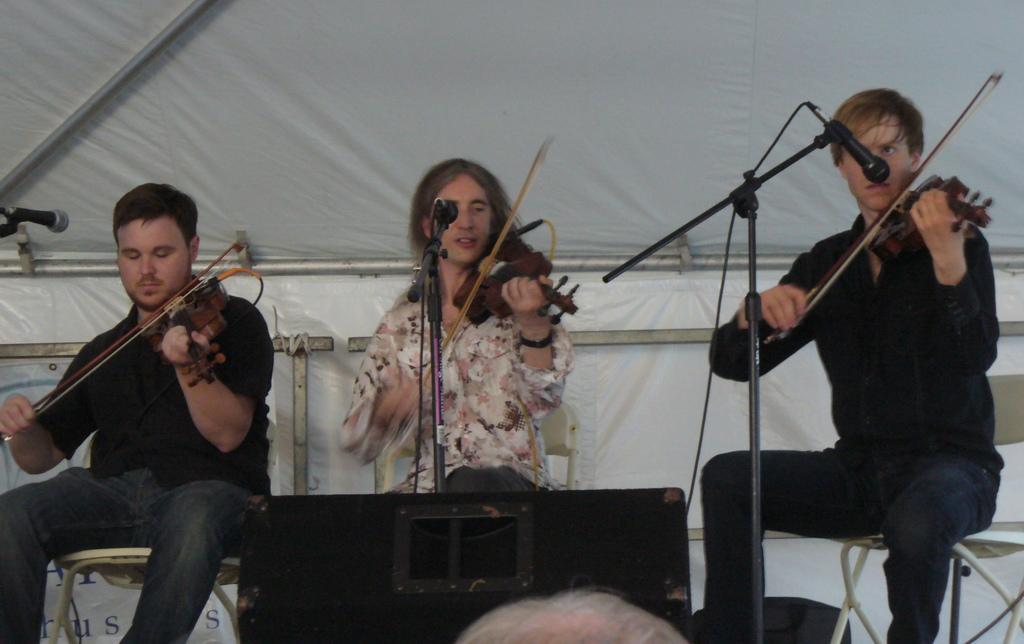In one or two sentences, can you explain what this image depicts? In the image we can see there are three people who are sitting on chair and holding violin in their hands. 